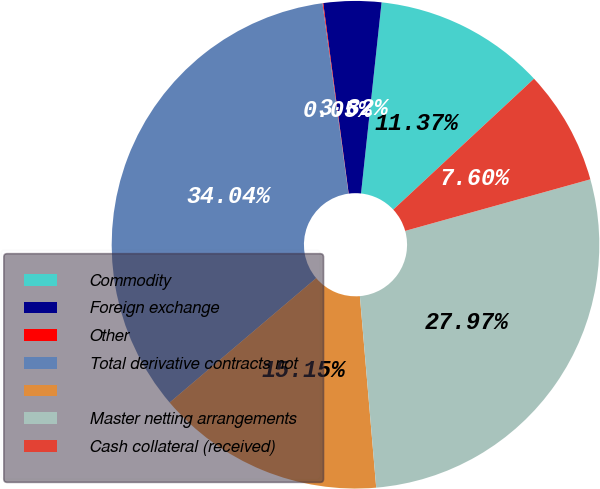Convert chart. <chart><loc_0><loc_0><loc_500><loc_500><pie_chart><fcel>Commodity<fcel>Foreign exchange<fcel>Other<fcel>Total derivative contracts not<fcel>Unnamed: 4<fcel>Master netting arrangements<fcel>Cash collateral (received)<nl><fcel>11.37%<fcel>3.82%<fcel>0.05%<fcel>34.04%<fcel>15.15%<fcel>27.97%<fcel>7.6%<nl></chart> 